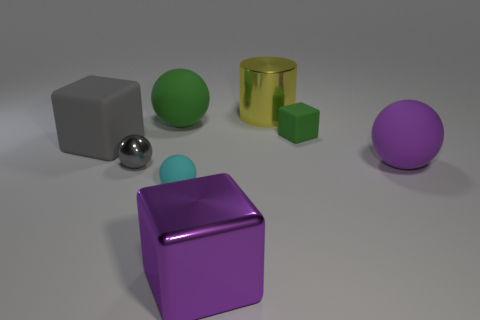There is a small thing behind the gray shiny ball; is it the same shape as the tiny metal thing?
Keep it short and to the point. No. How many gray objects are the same material as the large gray cube?
Give a very brief answer. 0. How many objects are rubber things that are in front of the small gray shiny object or large shiny objects?
Provide a succinct answer. 3. The gray shiny thing has what size?
Give a very brief answer. Small. The tiny block that is in front of the yellow cylinder that is right of the tiny metallic sphere is made of what material?
Offer a very short reply. Rubber. Do the purple thing to the right of the purple cube and the gray cube have the same size?
Provide a succinct answer. Yes. Are there any small metallic balls that have the same color as the big cylinder?
Ensure brevity in your answer.  No. How many things are either balls that are behind the tiny metallic object or rubber balls in front of the small gray ball?
Keep it short and to the point. 3. Is the color of the metal sphere the same as the large rubber cube?
Ensure brevity in your answer.  Yes. There is a small object that is the same color as the large matte block; what is its material?
Provide a short and direct response. Metal. 